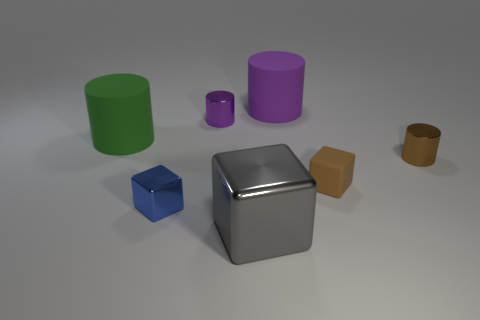Add 2 shiny objects. How many objects exist? 9 Subtract all gray cylinders. Subtract all brown cubes. How many cylinders are left? 4 Subtract all cubes. How many objects are left? 4 Subtract all red matte objects. Subtract all tiny metallic cubes. How many objects are left? 6 Add 6 small shiny cylinders. How many small shiny cylinders are left? 8 Add 5 blue metallic blocks. How many blue metallic blocks exist? 6 Subtract 1 purple cylinders. How many objects are left? 6 